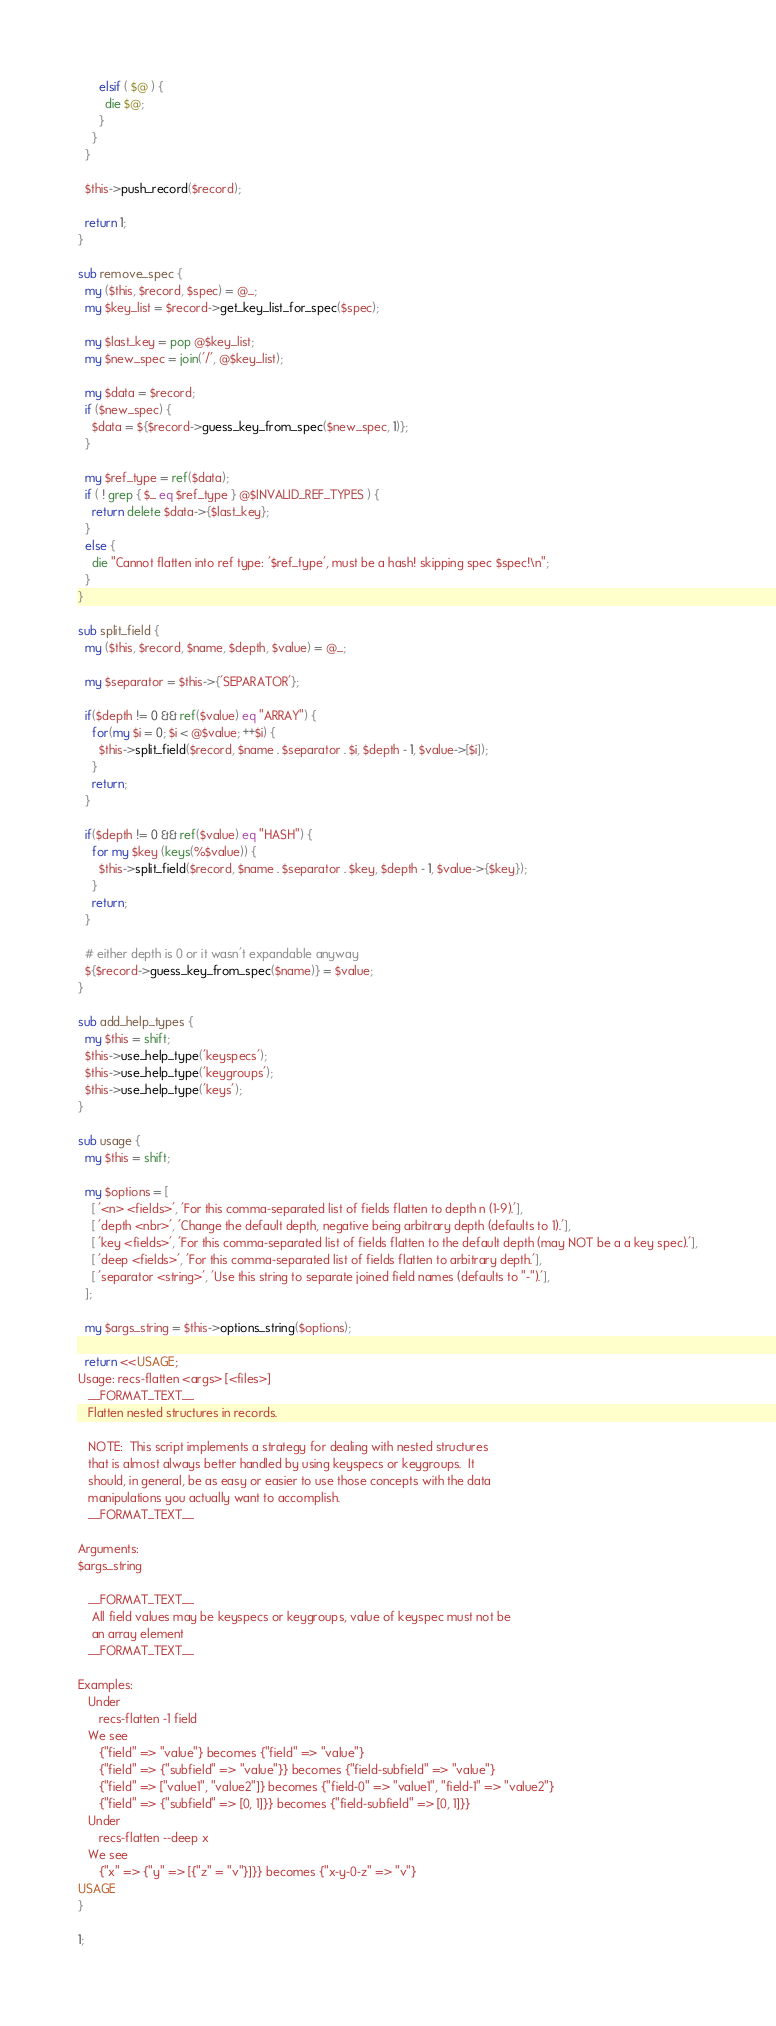<code> <loc_0><loc_0><loc_500><loc_500><_Perl_>      elsif ( $@ ) {
        die $@;
      }
    }
  }

  $this->push_record($record);

  return 1;
}

sub remove_spec {
  my ($this, $record, $spec) = @_;
  my $key_list = $record->get_key_list_for_spec($spec);

  my $last_key = pop @$key_list;
  my $new_spec = join('/', @$key_list);

  my $data = $record;
  if ($new_spec) {
    $data = ${$record->guess_key_from_spec($new_spec, 1)};
  }

  my $ref_type = ref($data);
  if ( ! grep { $_ eq $ref_type } @$INVALID_REF_TYPES ) {
    return delete $data->{$last_key};
  }
  else {
    die "Cannot flatten into ref type: '$ref_type', must be a hash! skipping spec $spec!\n";
  }
}

sub split_field {
  my ($this, $record, $name, $depth, $value) = @_;

  my $separator = $this->{'SEPARATOR'};

  if($depth != 0 && ref($value) eq "ARRAY") {
    for(my $i = 0; $i < @$value; ++$i) {
      $this->split_field($record, $name . $separator . $i, $depth - 1, $value->[$i]);
    }
    return;
  }

  if($depth != 0 && ref($value) eq "HASH") {
    for my $key (keys(%$value)) {
      $this->split_field($record, $name . $separator . $key, $depth - 1, $value->{$key});
    }
    return;
  }

  # either depth is 0 or it wasn't expandable anyway
  ${$record->guess_key_from_spec($name)} = $value;
}

sub add_help_types {
  my $this = shift;
  $this->use_help_type('keyspecs');
  $this->use_help_type('keygroups');
  $this->use_help_type('keys');
}

sub usage {
  my $this = shift;

  my $options = [
    [ '<n> <fields>', 'For this comma-separated list of fields flatten to depth n (1-9).'],
    [ 'depth <nbr>', 'Change the default depth, negative being arbitrary depth (defaults to 1).'],
    [ 'key <fields>', 'For this comma-separated list of fields flatten to the default depth (may NOT be a a key spec).'],
    [ 'deep <fields>', 'For this comma-separated list of fields flatten to arbitrary depth.'],
    [ 'separator <string>', 'Use this string to separate joined field names (defaults to "-").'],
  ];

  my $args_string = $this->options_string($options);

  return <<USAGE;
Usage: recs-flatten <args> [<files>]
   __FORMAT_TEXT__
   Flatten nested structures in records.

   NOTE:  This script implements a strategy for dealing with nested structures
   that is almost always better handled by using keyspecs or keygroups.  It
   should, in general, be as easy or easier to use those concepts with the data
   manipulations you actually want to accomplish.
   __FORMAT_TEXT__

Arguments:
$args_string

   __FORMAT_TEXT__
    All field values may be keyspecs or keygroups, value of keyspec must not be
    an array element
   __FORMAT_TEXT__

Examples:
   Under
      recs-flatten -1 field
   We see
      {"field" => "value"} becomes {"field" => "value"}
      {"field" => {"subfield" => "value"}} becomes {"field-subfield" => "value"}
      {"field" => ["value1", "value2"]} becomes {"field-0" => "value1", "field-1" => "value2"}
      {"field" => {"subfield" => [0, 1]}} becomes {"field-subfield" => [0, 1]}}
   Under
      recs-flatten --deep x
   We see
      {"x" => {"y" => [{"z" = "v"}]}} becomes {"x-y-0-z" => "v"}
USAGE
}

1;
</code> 